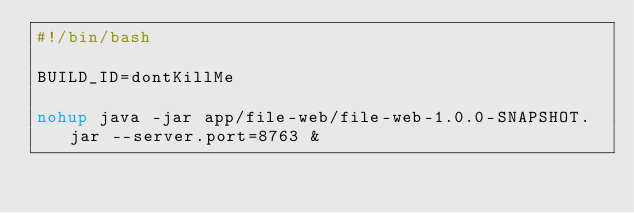Convert code to text. <code><loc_0><loc_0><loc_500><loc_500><_Bash_>#!/bin/bash

BUILD_ID=dontKillMe

nohup java -jar app/file-web/file-web-1.0.0-SNAPSHOT.jar --server.port=8763 &



</code> 